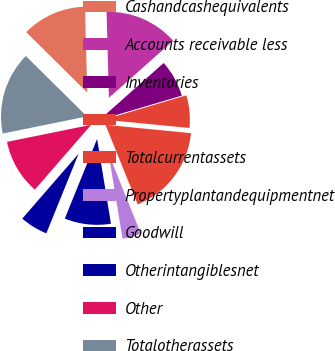Convert chart to OTSL. <chart><loc_0><loc_0><loc_500><loc_500><pie_chart><fcel>Cashandcashequivalents<fcel>Accounts receivable less<fcel>Inventories<fcel>Unnamed: 3<fcel>Totalcurrentassets<fcel>Propertyplantandequipmentnet<fcel>Goodwill<fcel>Otherintangiblesnet<fcel>Other<fcel>Totalotherassets<nl><fcel>12.16%<fcel>13.88%<fcel>6.98%<fcel>6.12%<fcel>17.34%<fcel>3.53%<fcel>8.71%<fcel>5.25%<fcel>10.43%<fcel>15.61%<nl></chart> 